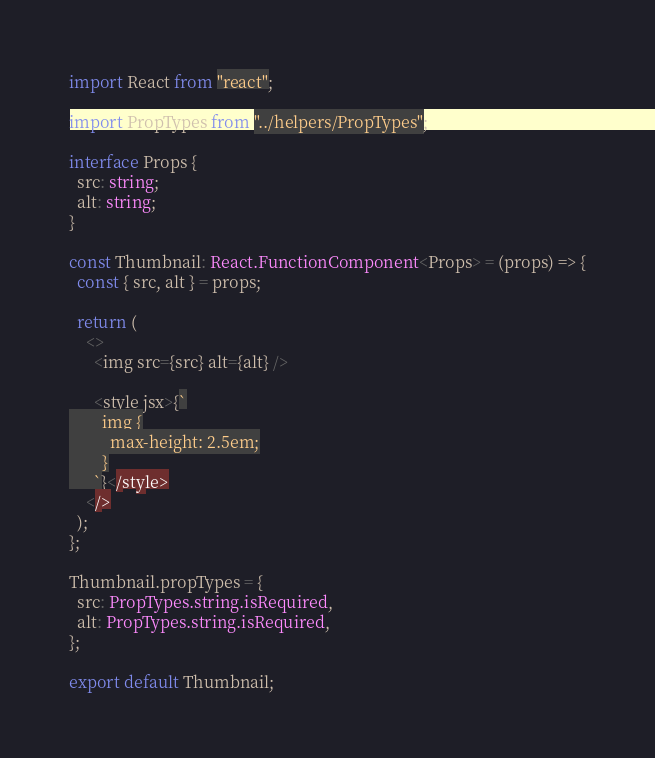Convert code to text. <code><loc_0><loc_0><loc_500><loc_500><_TypeScript_>import React from "react";

import PropTypes from "../helpers/PropTypes";

interface Props {
  src: string;
  alt: string;
}

const Thumbnail: React.FunctionComponent<Props> = (props) => {
  const { src, alt } = props;

  return (
    <>
      <img src={src} alt={alt} />

      <style jsx>{`
        img {
          max-height: 2.5em;
        }
      `}</style>
    </>
  );
};

Thumbnail.propTypes = {
  src: PropTypes.string.isRequired,
  alt: PropTypes.string.isRequired,
};

export default Thumbnail;
</code> 